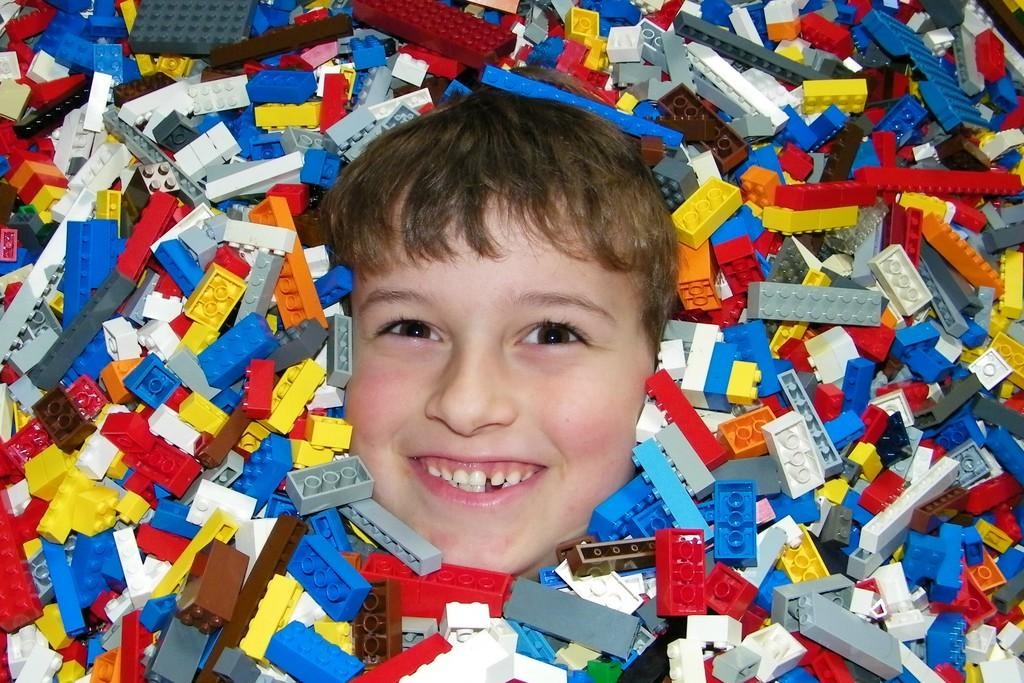What is the main subject of the picture? The main subject of the picture is a boy's face. What objects are surrounding the boy's face? Building blocks toys are around the boy's face. Can you describe the building blocks toys? The building blocks toys are in different colors. What type of harmony is being played in the background of the image? There is no music or harmony present in the image; it features a boy's face surrounded by building blocks toys. 